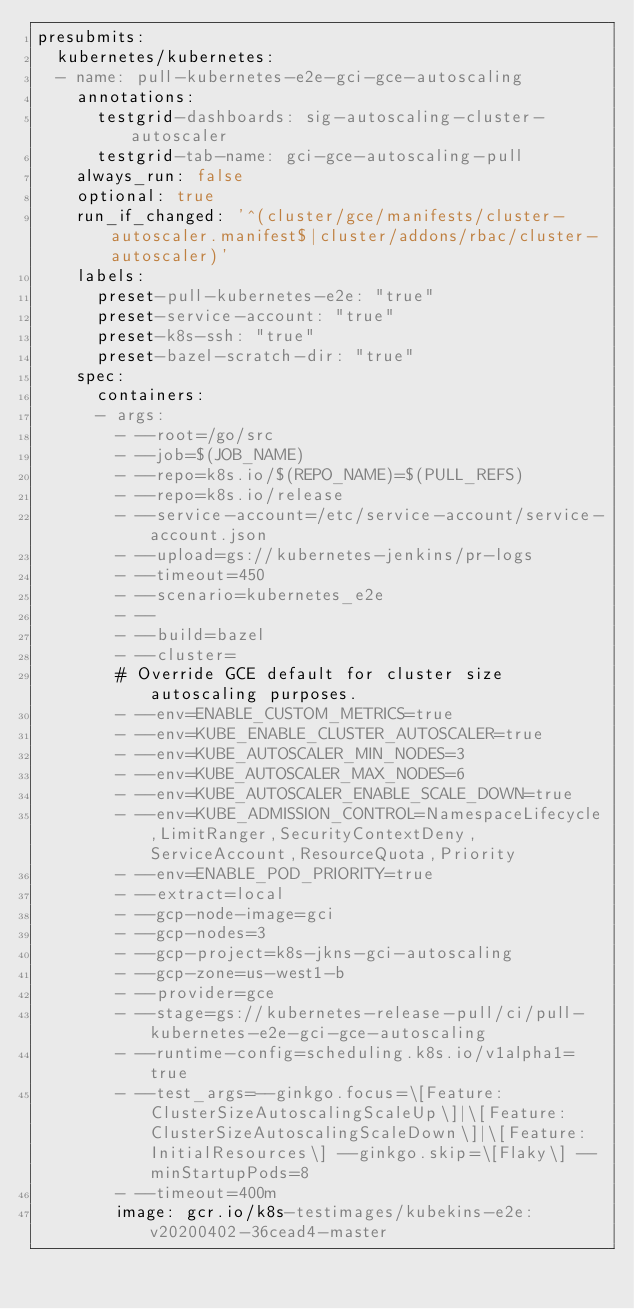<code> <loc_0><loc_0><loc_500><loc_500><_YAML_>presubmits:
  kubernetes/kubernetes:
  - name: pull-kubernetes-e2e-gci-gce-autoscaling
    annotations:
      testgrid-dashboards: sig-autoscaling-cluster-autoscaler
      testgrid-tab-name: gci-gce-autoscaling-pull
    always_run: false
    optional: true
    run_if_changed: '^(cluster/gce/manifests/cluster-autoscaler.manifest$|cluster/addons/rbac/cluster-autoscaler)'
    labels:
      preset-pull-kubernetes-e2e: "true"
      preset-service-account: "true"
      preset-k8s-ssh: "true"
      preset-bazel-scratch-dir: "true"
    spec:
      containers:
      - args:
        - --root=/go/src
        - --job=$(JOB_NAME)
        - --repo=k8s.io/$(REPO_NAME)=$(PULL_REFS)
        - --repo=k8s.io/release
        - --service-account=/etc/service-account/service-account.json
        - --upload=gs://kubernetes-jenkins/pr-logs
        - --timeout=450
        - --scenario=kubernetes_e2e
        - --
        - --build=bazel
        - --cluster=
        # Override GCE default for cluster size autoscaling purposes.
        - --env=ENABLE_CUSTOM_METRICS=true
        - --env=KUBE_ENABLE_CLUSTER_AUTOSCALER=true
        - --env=KUBE_AUTOSCALER_MIN_NODES=3
        - --env=KUBE_AUTOSCALER_MAX_NODES=6
        - --env=KUBE_AUTOSCALER_ENABLE_SCALE_DOWN=true
        - --env=KUBE_ADMISSION_CONTROL=NamespaceLifecycle,LimitRanger,SecurityContextDeny,ServiceAccount,ResourceQuota,Priority
        - --env=ENABLE_POD_PRIORITY=true
        - --extract=local
        - --gcp-node-image=gci
        - --gcp-nodes=3
        - --gcp-project=k8s-jkns-gci-autoscaling
        - --gcp-zone=us-west1-b
        - --provider=gce
        - --stage=gs://kubernetes-release-pull/ci/pull-kubernetes-e2e-gci-gce-autoscaling
        - --runtime-config=scheduling.k8s.io/v1alpha1=true
        - --test_args=--ginkgo.focus=\[Feature:ClusterSizeAutoscalingScaleUp\]|\[Feature:ClusterSizeAutoscalingScaleDown\]|\[Feature:InitialResources\] --ginkgo.skip=\[Flaky\] --minStartupPods=8
        - --timeout=400m
        image: gcr.io/k8s-testimages/kubekins-e2e:v20200402-36cead4-master
</code> 